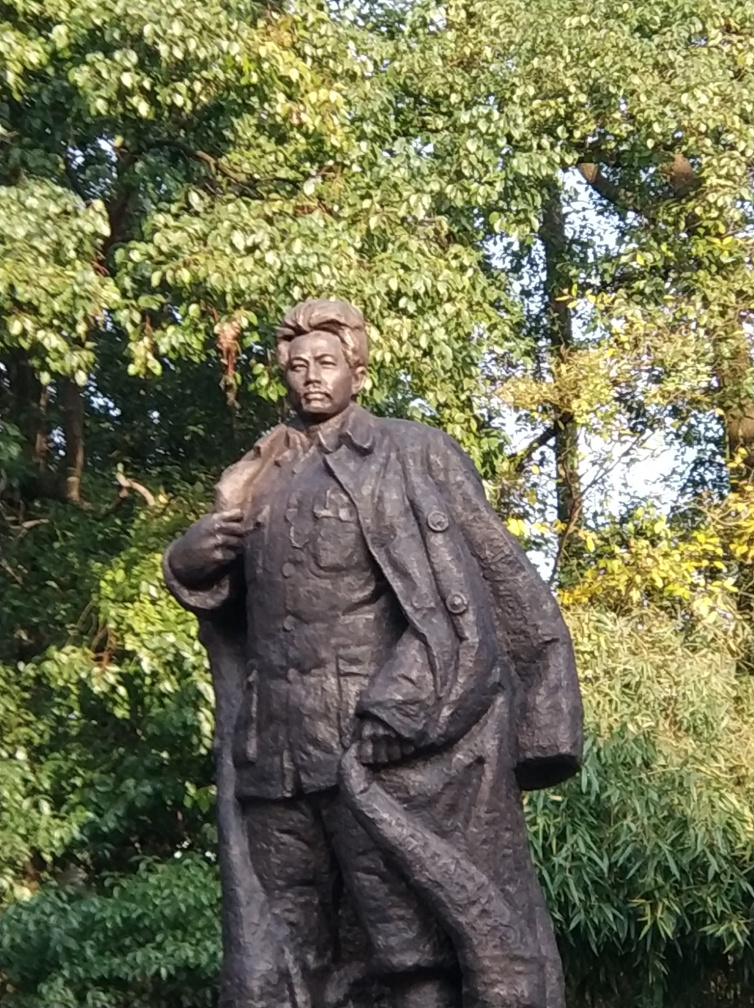How does the lighting in the photo affect the perception of the statue? The lighting in this image casts soft shadows across the statue, highlighting its contours and texture. The sunlight seems to be coming from the right, which illuminates one side of the statue, giving it a three-dimensional appearance that enhances its physical details. The interplay of light and shadow gives life to the subject and can invoke different emotional responses in viewers depending on the angle and intensity of the light. 